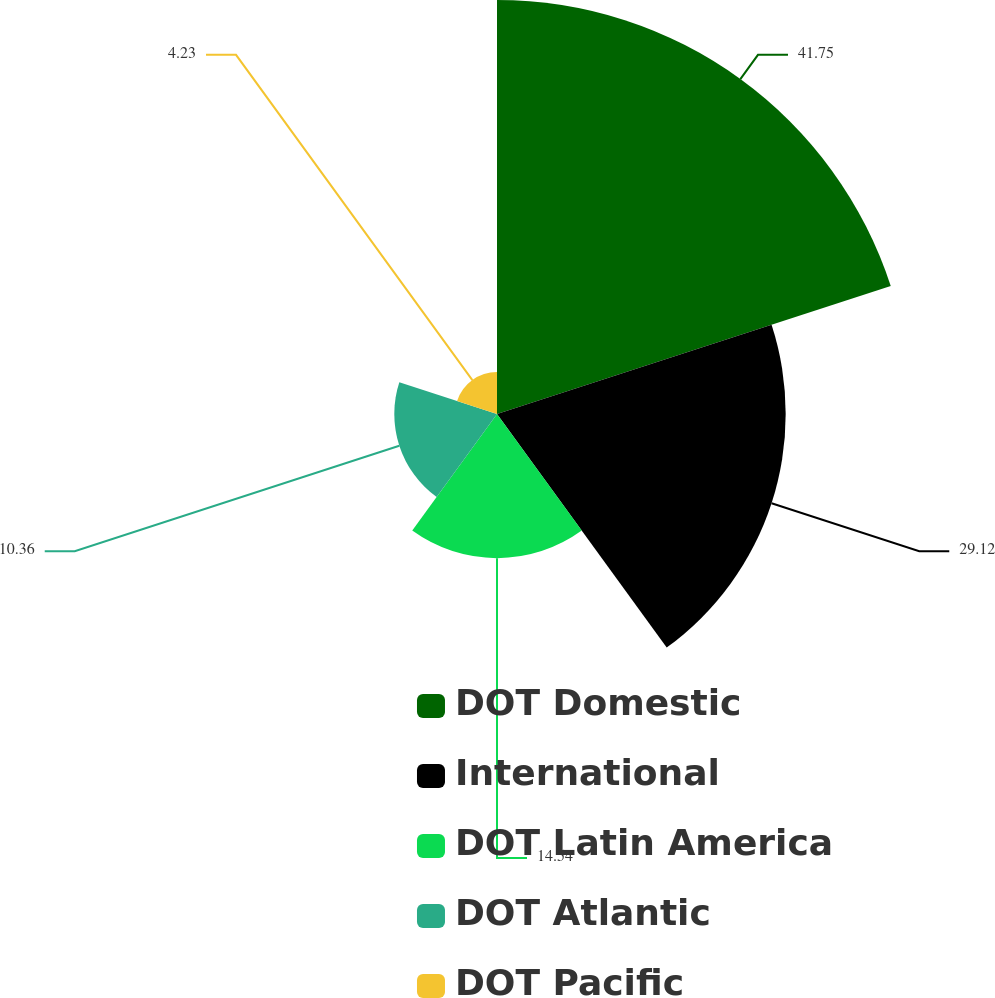<chart> <loc_0><loc_0><loc_500><loc_500><pie_chart><fcel>DOT Domestic<fcel>International<fcel>DOT Latin America<fcel>DOT Atlantic<fcel>DOT Pacific<nl><fcel>41.76%<fcel>29.12%<fcel>14.54%<fcel>10.36%<fcel>4.23%<nl></chart> 